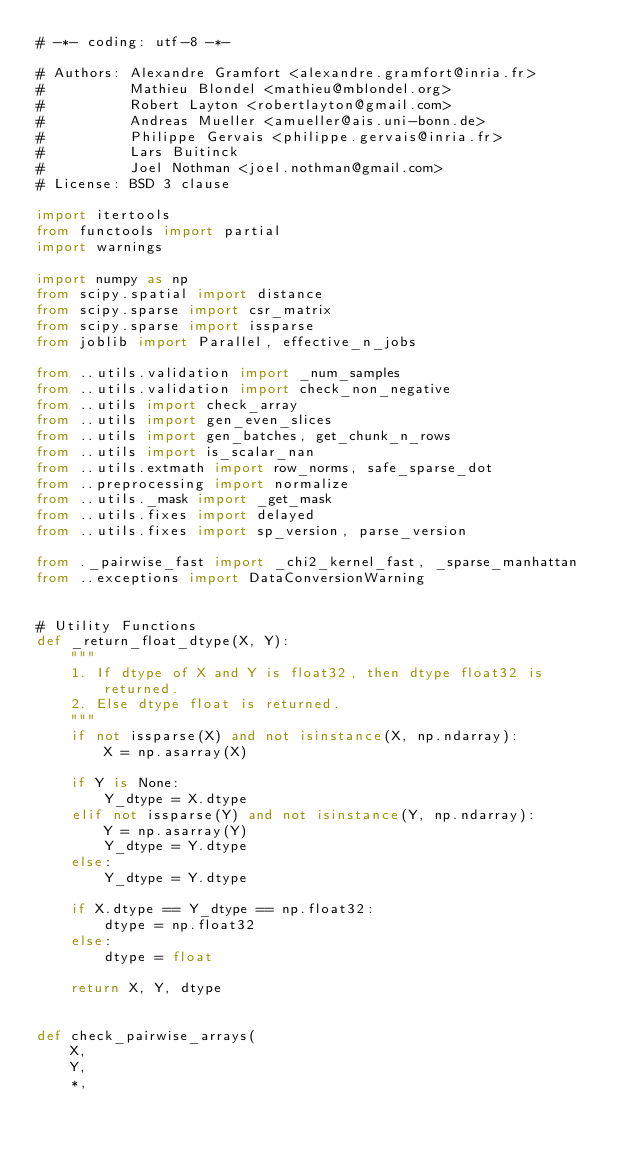Convert code to text. <code><loc_0><loc_0><loc_500><loc_500><_Python_># -*- coding: utf-8 -*-

# Authors: Alexandre Gramfort <alexandre.gramfort@inria.fr>
#          Mathieu Blondel <mathieu@mblondel.org>
#          Robert Layton <robertlayton@gmail.com>
#          Andreas Mueller <amueller@ais.uni-bonn.de>
#          Philippe Gervais <philippe.gervais@inria.fr>
#          Lars Buitinck
#          Joel Nothman <joel.nothman@gmail.com>
# License: BSD 3 clause

import itertools
from functools import partial
import warnings

import numpy as np
from scipy.spatial import distance
from scipy.sparse import csr_matrix
from scipy.sparse import issparse
from joblib import Parallel, effective_n_jobs

from ..utils.validation import _num_samples
from ..utils.validation import check_non_negative
from ..utils import check_array
from ..utils import gen_even_slices
from ..utils import gen_batches, get_chunk_n_rows
from ..utils import is_scalar_nan
from ..utils.extmath import row_norms, safe_sparse_dot
from ..preprocessing import normalize
from ..utils._mask import _get_mask
from ..utils.fixes import delayed
from ..utils.fixes import sp_version, parse_version

from ._pairwise_fast import _chi2_kernel_fast, _sparse_manhattan
from ..exceptions import DataConversionWarning


# Utility Functions
def _return_float_dtype(X, Y):
    """
    1. If dtype of X and Y is float32, then dtype float32 is returned.
    2. Else dtype float is returned.
    """
    if not issparse(X) and not isinstance(X, np.ndarray):
        X = np.asarray(X)

    if Y is None:
        Y_dtype = X.dtype
    elif not issparse(Y) and not isinstance(Y, np.ndarray):
        Y = np.asarray(Y)
        Y_dtype = Y.dtype
    else:
        Y_dtype = Y.dtype

    if X.dtype == Y_dtype == np.float32:
        dtype = np.float32
    else:
        dtype = float

    return X, Y, dtype


def check_pairwise_arrays(
    X,
    Y,
    *,</code> 